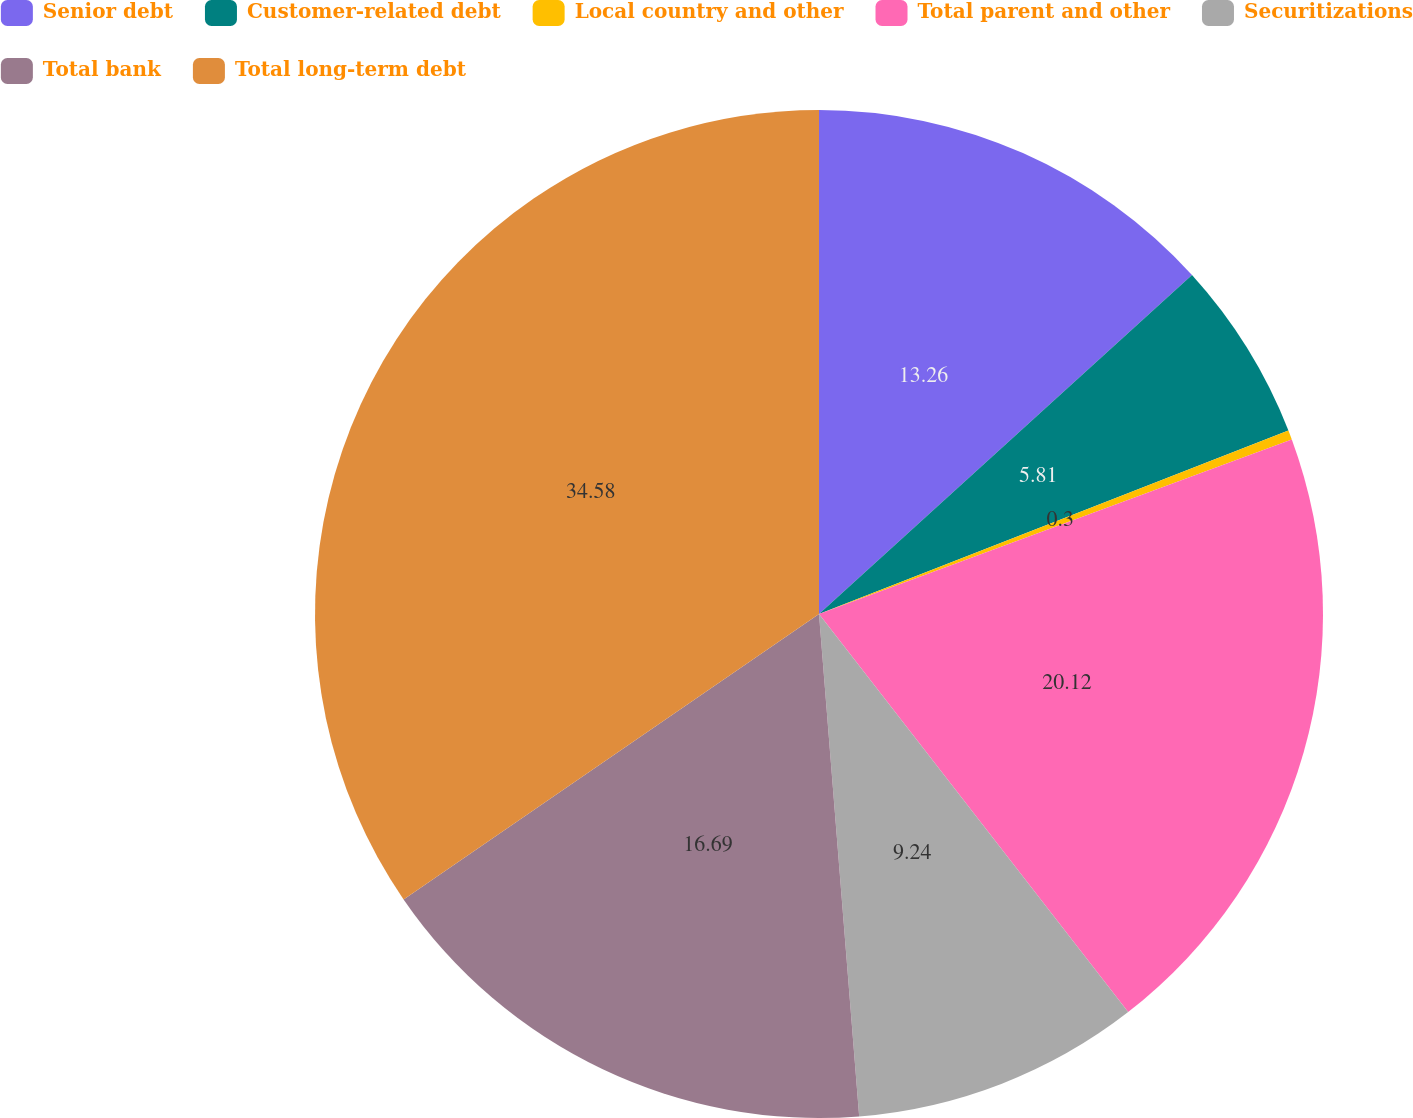Convert chart to OTSL. <chart><loc_0><loc_0><loc_500><loc_500><pie_chart><fcel>Senior debt<fcel>Customer-related debt<fcel>Local country and other<fcel>Total parent and other<fcel>Securitizations<fcel>Total bank<fcel>Total long-term debt<nl><fcel>13.26%<fcel>5.81%<fcel>0.3%<fcel>20.12%<fcel>9.24%<fcel>16.69%<fcel>34.58%<nl></chart> 